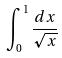<formula> <loc_0><loc_0><loc_500><loc_500>\int _ { 0 } ^ { 1 } \frac { d x } { \sqrt { x } }</formula> 